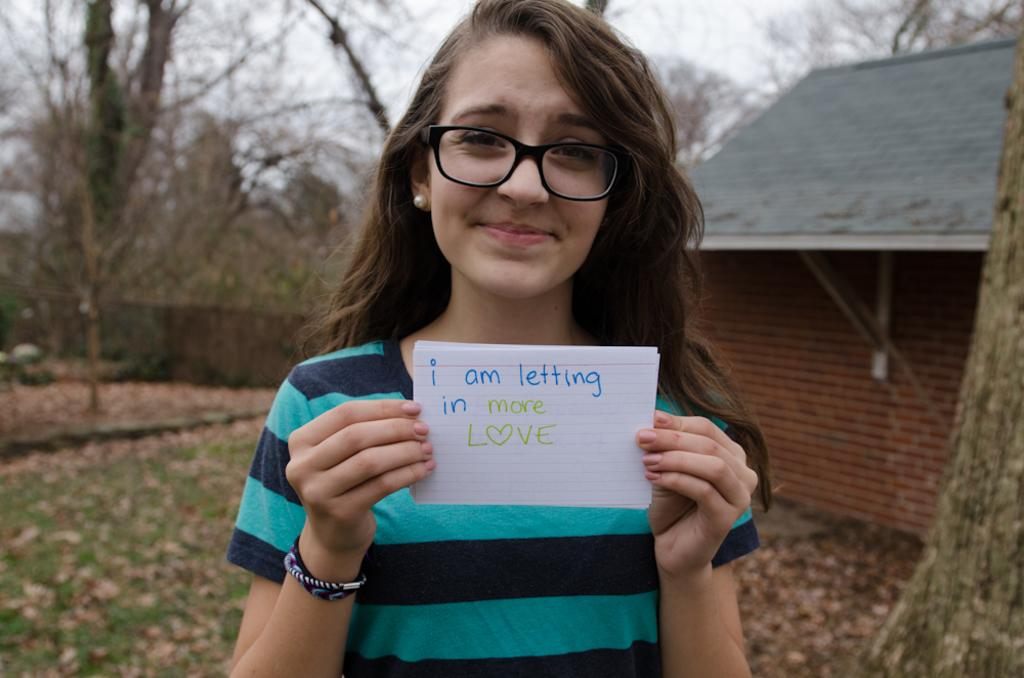What is the person in the image doing? The person is standing in the image and holding a paper. What can be seen in the background of the image? There is a house, trees, and the sky visible in the background. What is the person holding in the image? The person is holding a paper. Can you describe the natural elements in the image? Yes, there are trees in the image. What level of friction is present between the person's ear and the paper in the image? There is no information about the person's ear or the friction between the ear and the paper in the image. 